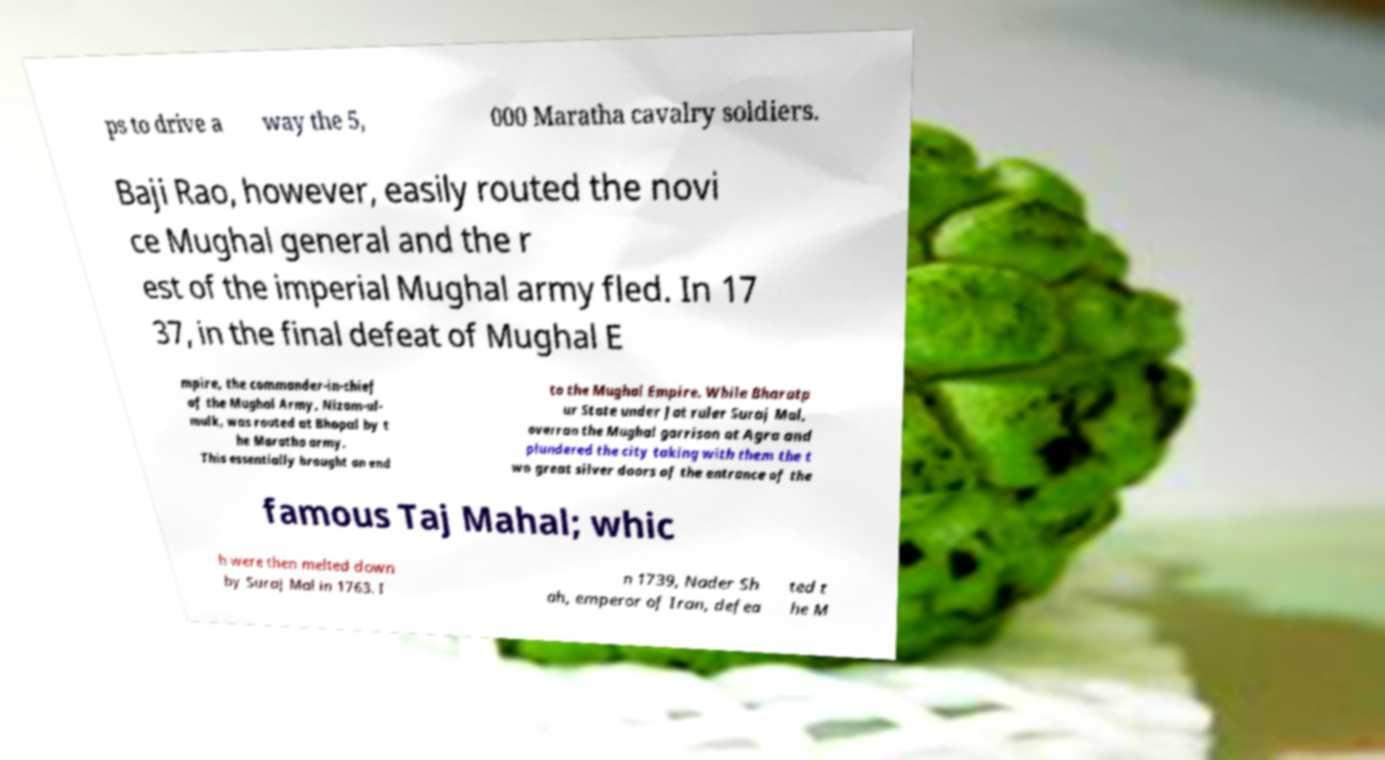For documentation purposes, I need the text within this image transcribed. Could you provide that? ps to drive a way the 5, 000 Maratha cavalry soldiers. Baji Rao, however, easily routed the novi ce Mughal general and the r est of the imperial Mughal army fled. In 17 37, in the final defeat of Mughal E mpire, the commander-in-chief of the Mughal Army, Nizam-ul- mulk, was routed at Bhopal by t he Maratha army. This essentially brought an end to the Mughal Empire. While Bharatp ur State under Jat ruler Suraj Mal, overran the Mughal garrison at Agra and plundered the city taking with them the t wo great silver doors of the entrance of the famous Taj Mahal; whic h were then melted down by Suraj Mal in 1763. I n 1739, Nader Sh ah, emperor of Iran, defea ted t he M 